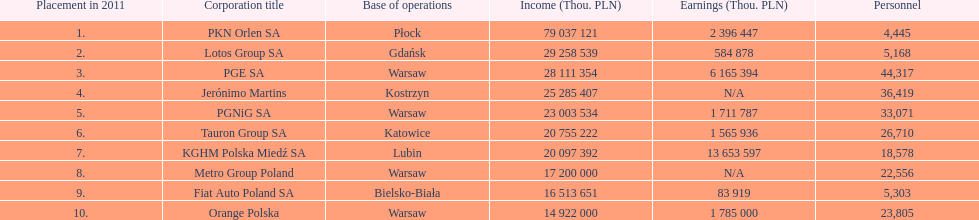What is the difference in employees for rank 1 and rank 3? 39,872 employees. 